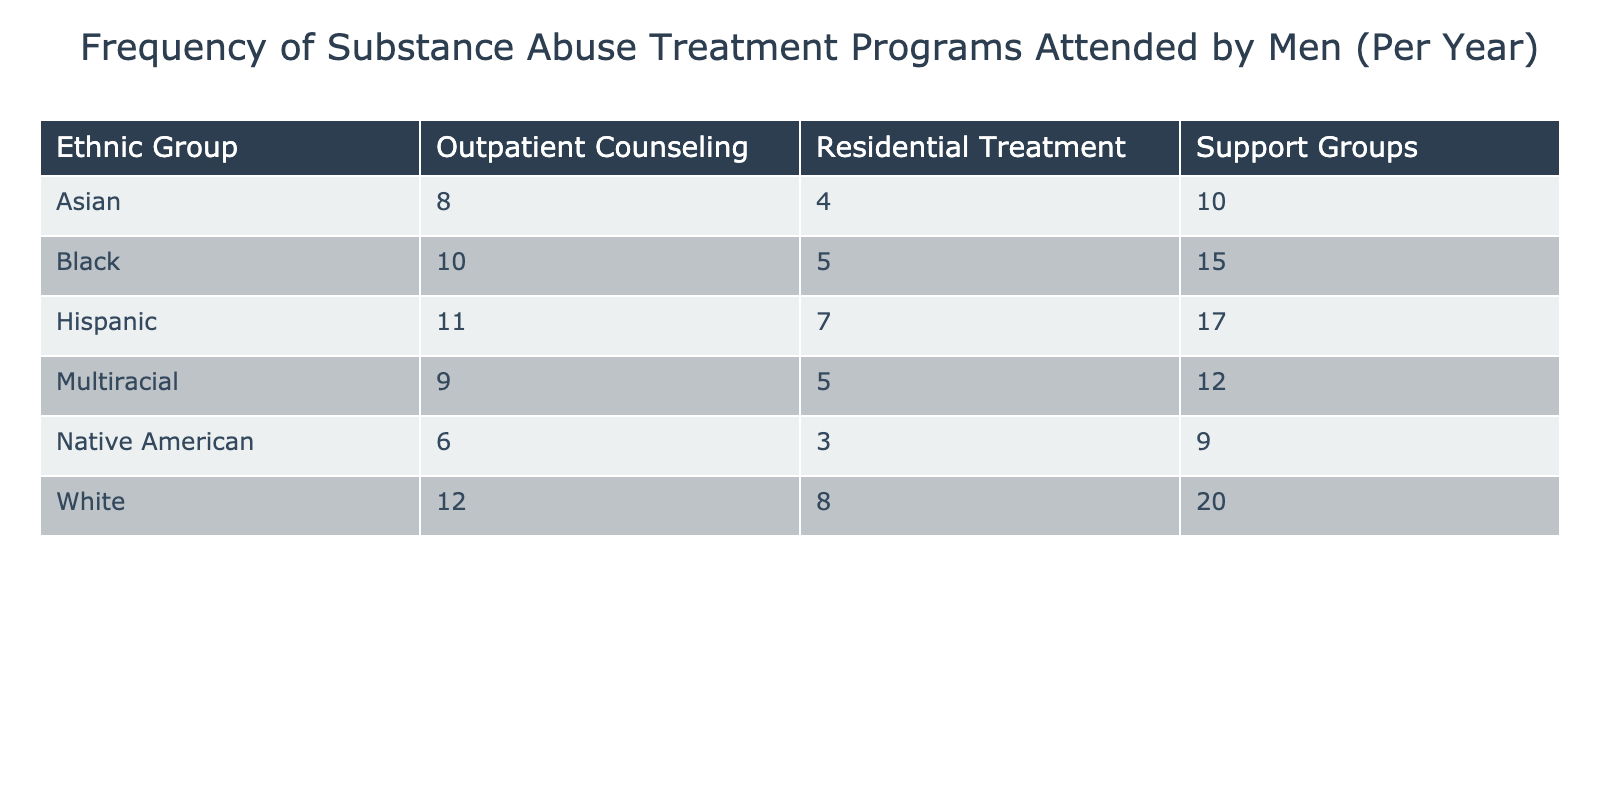What is the frequency of outpatient counseling attended by Hispanic men? The frequency for Hispanic men in outpatient counseling is listed directly in the table under the corresponding ethnic group and treatment program. That value is 11.
Answer: 11 Which ethnic group attended the most support groups? To find the group with the highest attendance in support groups, we need to check the frequency values for support groups listed for each ethnic group and compare them. The highest value is 20 for White men.
Answer: 20 What is the total frequency of residential treatment programs attended by Black and Asian men combined? To find the combined frequency, we look at the frequencies for Black men (5) and Asian men (4) in residential treatment. Adding these two values (5 + 4) gives us 9.
Answer: 9 Did Native American men attend more outpatient counseling or residential treatment? We can compare the two values for Native American men: outpatient counseling (6) and residential treatment (3). Outpatient counseling (6) is greater than residential treatment (3).
Answer: Yes What is the average frequency of outpatient counseling across all ethnic groups? First, we identify the outpatient counseling frequencies: 12 (White), 10 (Black), 11 (Hispanic), 8 (Asian), 6 (Native American), and 9 (Multiracial). The total is 56, and there are 6 groups: 56/6 equals approximately 9.33.
Answer: 9.33 Which ethnic group attended more treatment programs overall: Multiracial or Black? We need to sum the frequencies for both ethnic groups. For Black: 10 (outpatient) + 5 (residential) + 15 (support) = 30. For Multiracial: 9 (outpatient) + 5 (residential) + 12 (support) = 26. Black men attended more treatment programs.
Answer: Black Is it true that Asian men attended fewer support groups than White men? The frequency of support groups for Asian men is 10, while for White men it is 20. Since 10 is less than 20, the statement is true.
Answer: Yes What is the difference in frequencies of support group attendance between White and Hispanic men? For White men, the frequency is 20 and for Hispanic men, it is 17. The difference is calculated by subtracting Hispanic from White, which is 20 - 17 = 3.
Answer: 3 What is the total attendance for all treatment programs by Hispanic men? We sum the frequencies for Hispanic men in all treatment programs: 11 (outpatient) + 7 (residential) + 17 (support) which equals 35.
Answer: 35 How many more sessions did White men attend in support groups compared to Native American men? The support group frequency for White men is 20 and for Native American men it is 9. Subtracting gives us 20 - 9 = 11.
Answer: 11 